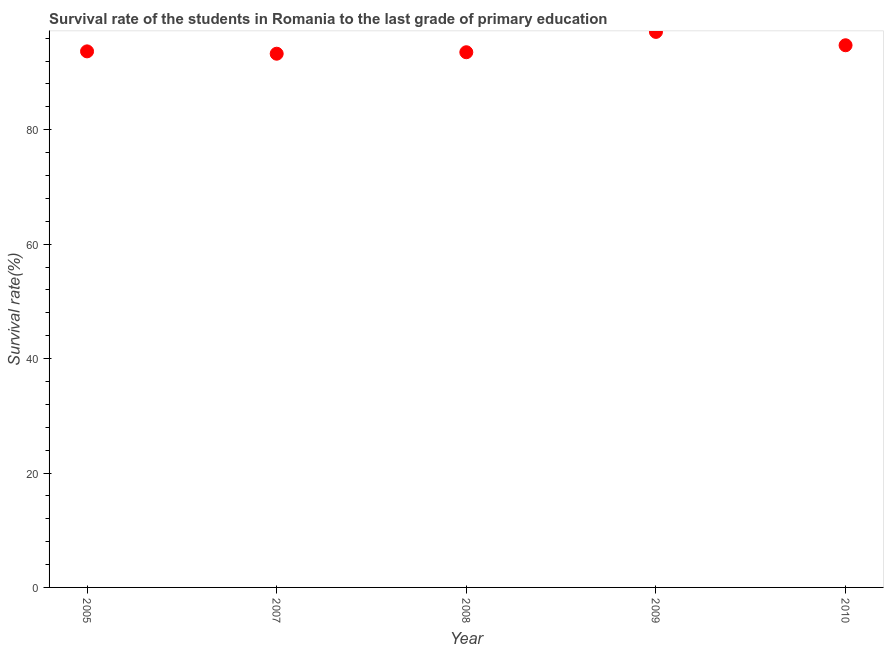What is the survival rate in primary education in 2009?
Your answer should be compact. 97.1. Across all years, what is the maximum survival rate in primary education?
Your answer should be very brief. 97.1. Across all years, what is the minimum survival rate in primary education?
Provide a short and direct response. 93.29. In which year was the survival rate in primary education minimum?
Provide a short and direct response. 2007. What is the sum of the survival rate in primary education?
Give a very brief answer. 472.41. What is the difference between the survival rate in primary education in 2009 and 2010?
Your response must be concise. 2.33. What is the average survival rate in primary education per year?
Give a very brief answer. 94.48. What is the median survival rate in primary education?
Give a very brief answer. 93.7. In how many years, is the survival rate in primary education greater than 20 %?
Make the answer very short. 5. What is the ratio of the survival rate in primary education in 2005 to that in 2008?
Provide a short and direct response. 1. What is the difference between the highest and the second highest survival rate in primary education?
Keep it short and to the point. 2.33. Is the sum of the survival rate in primary education in 2005 and 2008 greater than the maximum survival rate in primary education across all years?
Keep it short and to the point. Yes. What is the difference between the highest and the lowest survival rate in primary education?
Your answer should be compact. 3.81. Does the survival rate in primary education monotonically increase over the years?
Make the answer very short. No. How many years are there in the graph?
Provide a succinct answer. 5. What is the difference between two consecutive major ticks on the Y-axis?
Provide a succinct answer. 20. Does the graph contain grids?
Keep it short and to the point. No. What is the title of the graph?
Give a very brief answer. Survival rate of the students in Romania to the last grade of primary education. What is the label or title of the Y-axis?
Make the answer very short. Survival rate(%). What is the Survival rate(%) in 2005?
Make the answer very short. 93.7. What is the Survival rate(%) in 2007?
Offer a very short reply. 93.29. What is the Survival rate(%) in 2008?
Give a very brief answer. 93.55. What is the Survival rate(%) in 2009?
Provide a short and direct response. 97.1. What is the Survival rate(%) in 2010?
Keep it short and to the point. 94.77. What is the difference between the Survival rate(%) in 2005 and 2007?
Offer a very short reply. 0.41. What is the difference between the Survival rate(%) in 2005 and 2008?
Give a very brief answer. 0.15. What is the difference between the Survival rate(%) in 2005 and 2009?
Provide a short and direct response. -3.4. What is the difference between the Survival rate(%) in 2005 and 2010?
Provide a short and direct response. -1.07. What is the difference between the Survival rate(%) in 2007 and 2008?
Your response must be concise. -0.26. What is the difference between the Survival rate(%) in 2007 and 2009?
Offer a terse response. -3.81. What is the difference between the Survival rate(%) in 2007 and 2010?
Your answer should be very brief. -1.48. What is the difference between the Survival rate(%) in 2008 and 2009?
Ensure brevity in your answer.  -3.55. What is the difference between the Survival rate(%) in 2008 and 2010?
Offer a terse response. -1.22. What is the difference between the Survival rate(%) in 2009 and 2010?
Your answer should be compact. 2.33. What is the ratio of the Survival rate(%) in 2007 to that in 2008?
Your answer should be very brief. 1. What is the ratio of the Survival rate(%) in 2007 to that in 2009?
Give a very brief answer. 0.96. What is the ratio of the Survival rate(%) in 2008 to that in 2009?
Provide a short and direct response. 0.96. What is the ratio of the Survival rate(%) in 2009 to that in 2010?
Your answer should be compact. 1.02. 